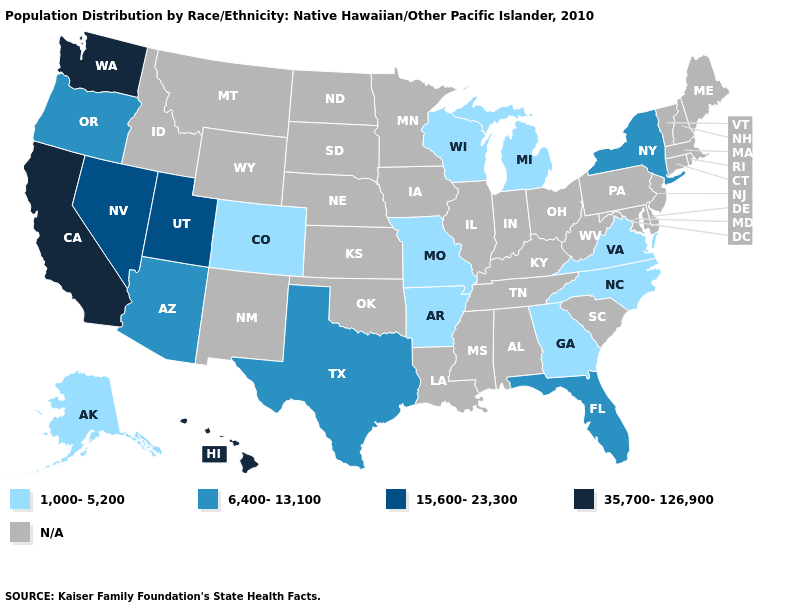Does the first symbol in the legend represent the smallest category?
Write a very short answer. Yes. Does Florida have the lowest value in the South?
Answer briefly. No. Name the states that have a value in the range 6,400-13,100?
Concise answer only. Arizona, Florida, New York, Oregon, Texas. Name the states that have a value in the range N/A?
Concise answer only. Alabama, Connecticut, Delaware, Idaho, Illinois, Indiana, Iowa, Kansas, Kentucky, Louisiana, Maine, Maryland, Massachusetts, Minnesota, Mississippi, Montana, Nebraska, New Hampshire, New Jersey, New Mexico, North Dakota, Ohio, Oklahoma, Pennsylvania, Rhode Island, South Carolina, South Dakota, Tennessee, Vermont, West Virginia, Wyoming. Does the map have missing data?
Write a very short answer. Yes. Is the legend a continuous bar?
Be succinct. No. Does Washington have the highest value in the USA?
Keep it brief. Yes. What is the highest value in the USA?
Keep it brief. 35,700-126,900. What is the value of Colorado?
Write a very short answer. 1,000-5,200. Which states have the lowest value in the USA?
Quick response, please. Alaska, Arkansas, Colorado, Georgia, Michigan, Missouri, North Carolina, Virginia, Wisconsin. What is the value of Kansas?
Keep it brief. N/A. What is the value of Louisiana?
Keep it brief. N/A. Name the states that have a value in the range 35,700-126,900?
Give a very brief answer. California, Hawaii, Washington. 